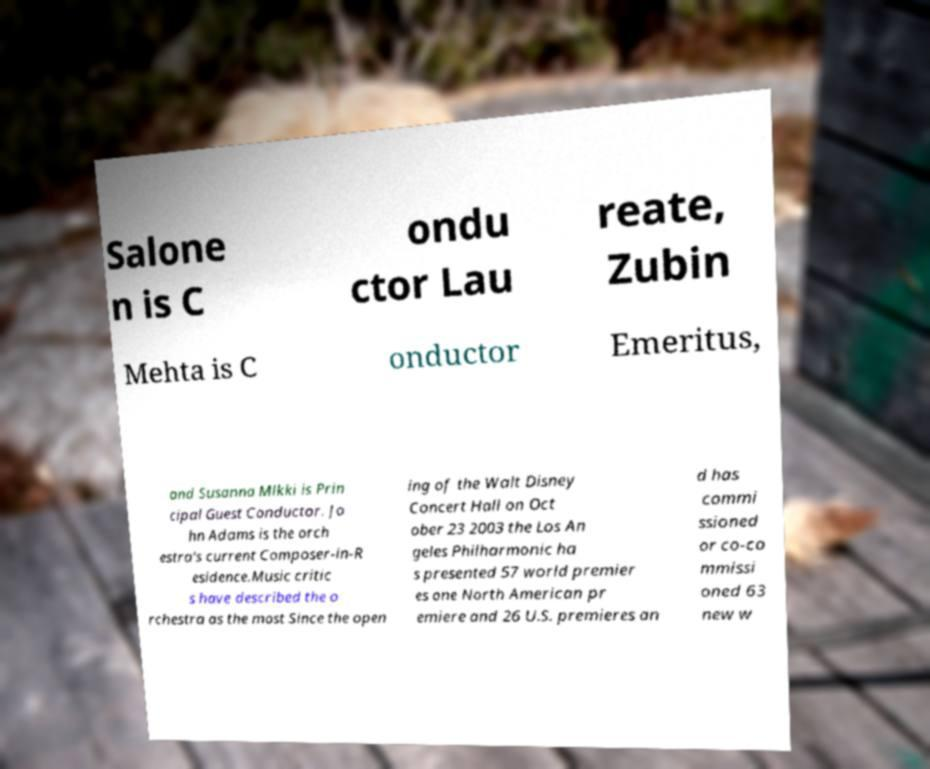Could you extract and type out the text from this image? Salone n is C ondu ctor Lau reate, Zubin Mehta is C onductor Emeritus, and Susanna Mlkki is Prin cipal Guest Conductor. Jo hn Adams is the orch estra's current Composer-in-R esidence.Music critic s have described the o rchestra as the most Since the open ing of the Walt Disney Concert Hall on Oct ober 23 2003 the Los An geles Philharmonic ha s presented 57 world premier es one North American pr emiere and 26 U.S. premieres an d has commi ssioned or co-co mmissi oned 63 new w 